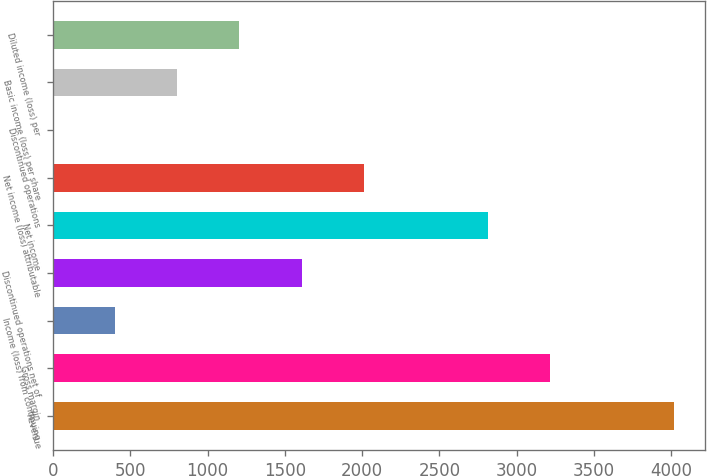Convert chart. <chart><loc_0><loc_0><loc_500><loc_500><bar_chart><fcel>Revenue<fcel>Gross margin<fcel>Income (loss) from continuing<fcel>Discontinued operations net of<fcel>Net income<fcel>Net income (loss) attributable<fcel>Discontinued operations<fcel>Basic income (loss) per share<fcel>Diluted income (loss) per<nl><fcel>4021<fcel>3216.81<fcel>402.11<fcel>1608.41<fcel>2814.71<fcel>2010.51<fcel>0.01<fcel>804.21<fcel>1206.31<nl></chart> 